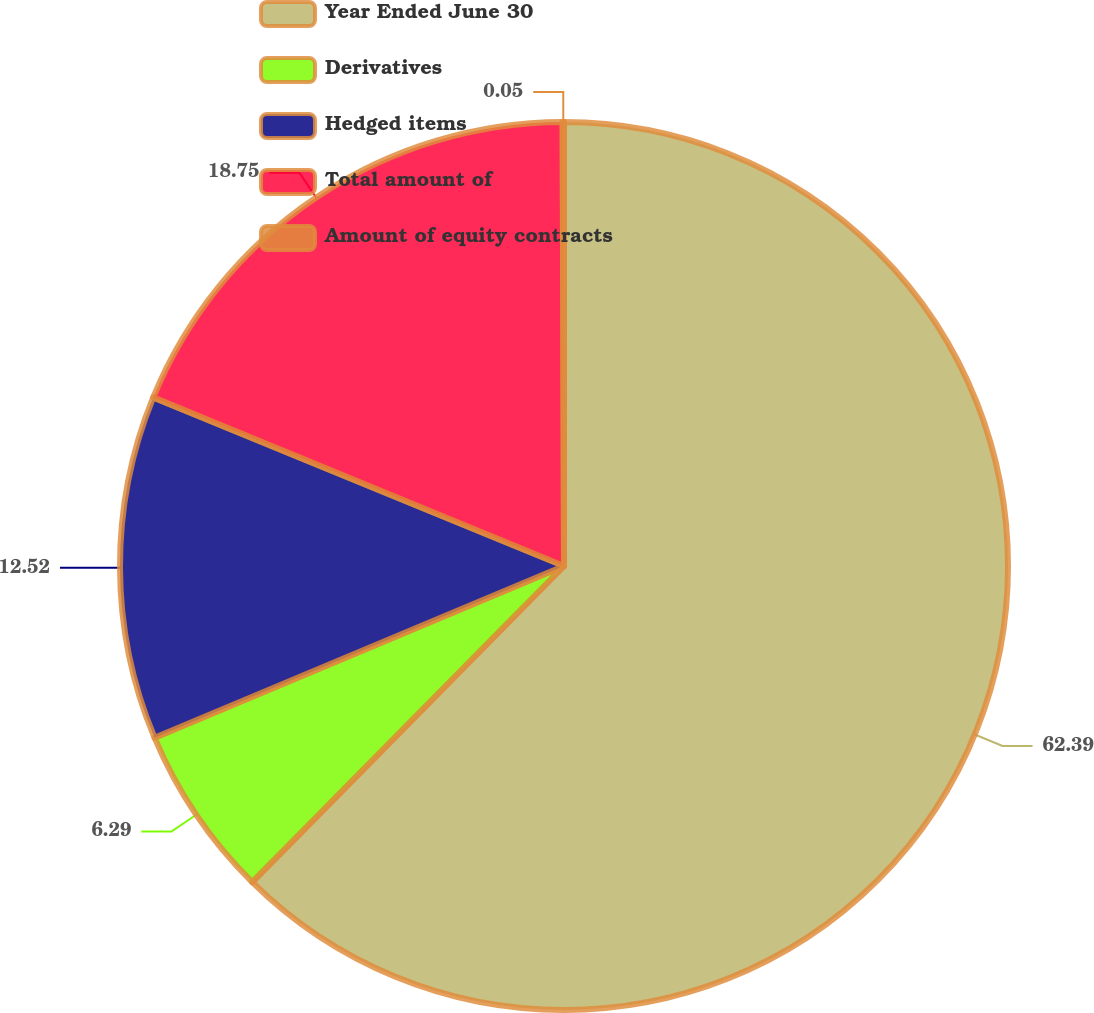Convert chart. <chart><loc_0><loc_0><loc_500><loc_500><pie_chart><fcel>Year Ended June 30<fcel>Derivatives<fcel>Hedged items<fcel>Total amount of<fcel>Amount of equity contracts<nl><fcel>62.39%<fcel>6.29%<fcel>12.52%<fcel>18.75%<fcel>0.05%<nl></chart> 